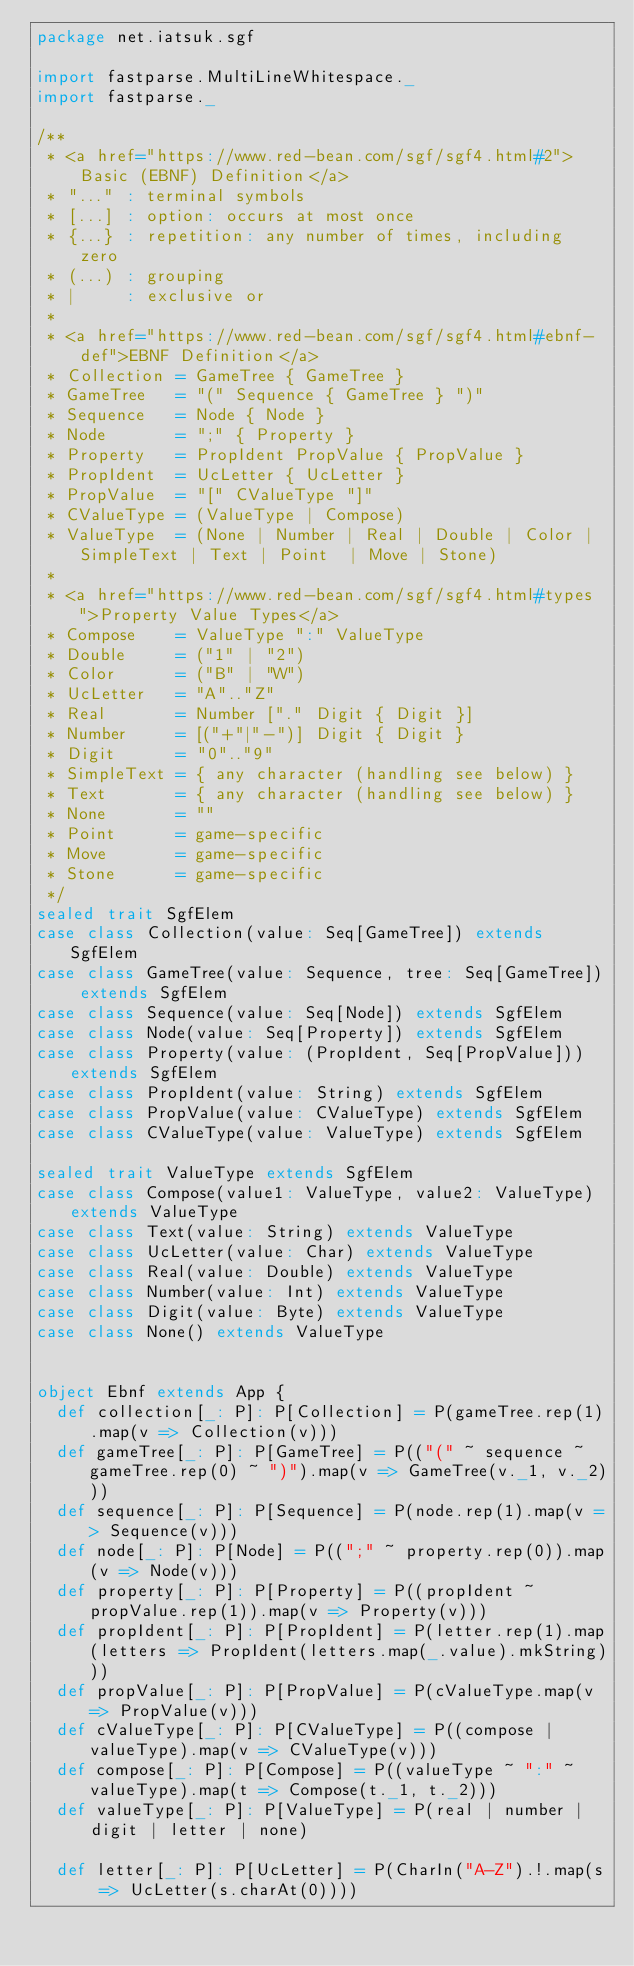Convert code to text. <code><loc_0><loc_0><loc_500><loc_500><_Scala_>package net.iatsuk.sgf

import fastparse.MultiLineWhitespace._
import fastparse._

/**
 * <a href="https://www.red-bean.com/sgf/sgf4.html#2">Basic (EBNF) Definition</a>
 * "..." : terminal symbols
 * [...] : option: occurs at most once
 * {...} : repetition: any number of times, including zero
 * (...) : grouping
 * |     : exclusive or
 *
 * <a href="https://www.red-bean.com/sgf/sgf4.html#ebnf-def">EBNF Definition</a>
 * Collection = GameTree { GameTree }
 * GameTree   = "(" Sequence { GameTree } ")"
 * Sequence   = Node { Node }
 * Node       = ";" { Property }
 * Property   = PropIdent PropValue { PropValue }
 * PropIdent  = UcLetter { UcLetter }
 * PropValue  = "[" CValueType "]"
 * CValueType = (ValueType | Compose)
 * ValueType  = (None | Number | Real | Double | Color | SimpleText | Text | Point  | Move | Stone)
 *
 * <a href="https://www.red-bean.com/sgf/sgf4.html#types">Property Value Types</a>
 * Compose    = ValueType ":" ValueType
 * Double     = ("1" | "2")
 * Color      = ("B" | "W")
 * UcLetter   = "A".."Z"
 * Real       = Number ["." Digit { Digit }]
 * Number     = [("+"|"-")] Digit { Digit }
 * Digit      = "0".."9"
 * SimpleText = { any character (handling see below) }
 * Text       = { any character (handling see below) }
 * None       = ""
 * Point      = game-specific
 * Move       = game-specific
 * Stone      = game-specific
 */
sealed trait SgfElem
case class Collection(value: Seq[GameTree]) extends SgfElem
case class GameTree(value: Sequence, tree: Seq[GameTree]) extends SgfElem
case class Sequence(value: Seq[Node]) extends SgfElem
case class Node(value: Seq[Property]) extends SgfElem
case class Property(value: (PropIdent, Seq[PropValue])) extends SgfElem
case class PropIdent(value: String) extends SgfElem
case class PropValue(value: CValueType) extends SgfElem
case class CValueType(value: ValueType) extends SgfElem

sealed trait ValueType extends SgfElem
case class Compose(value1: ValueType, value2: ValueType) extends ValueType
case class Text(value: String) extends ValueType
case class UcLetter(value: Char) extends ValueType
case class Real(value: Double) extends ValueType
case class Number(value: Int) extends ValueType
case class Digit(value: Byte) extends ValueType
case class None() extends ValueType


object Ebnf extends App {
  def collection[_: P]: P[Collection] = P(gameTree.rep(1).map(v => Collection(v)))
  def gameTree[_: P]: P[GameTree] = P(("(" ~ sequence ~ gameTree.rep(0) ~ ")").map(v => GameTree(v._1, v._2)))
  def sequence[_: P]: P[Sequence] = P(node.rep(1).map(v => Sequence(v)))
  def node[_: P]: P[Node] = P((";" ~ property.rep(0)).map(v => Node(v)))
  def property[_: P]: P[Property] = P((propIdent ~ propValue.rep(1)).map(v => Property(v)))
  def propIdent[_: P]: P[PropIdent] = P(letter.rep(1).map(letters => PropIdent(letters.map(_.value).mkString)))
  def propValue[_: P]: P[PropValue] = P(cValueType.map(v => PropValue(v)))
  def cValueType[_: P]: P[CValueType] = P((compose | valueType).map(v => CValueType(v)))
  def compose[_: P]: P[Compose] = P((valueType ~ ":" ~ valueType).map(t => Compose(t._1, t._2)))
  def valueType[_: P]: P[ValueType] = P(real | number | digit | letter | none)

  def letter[_: P]: P[UcLetter] = P(CharIn("A-Z").!.map(s => UcLetter(s.charAt(0))))</code> 